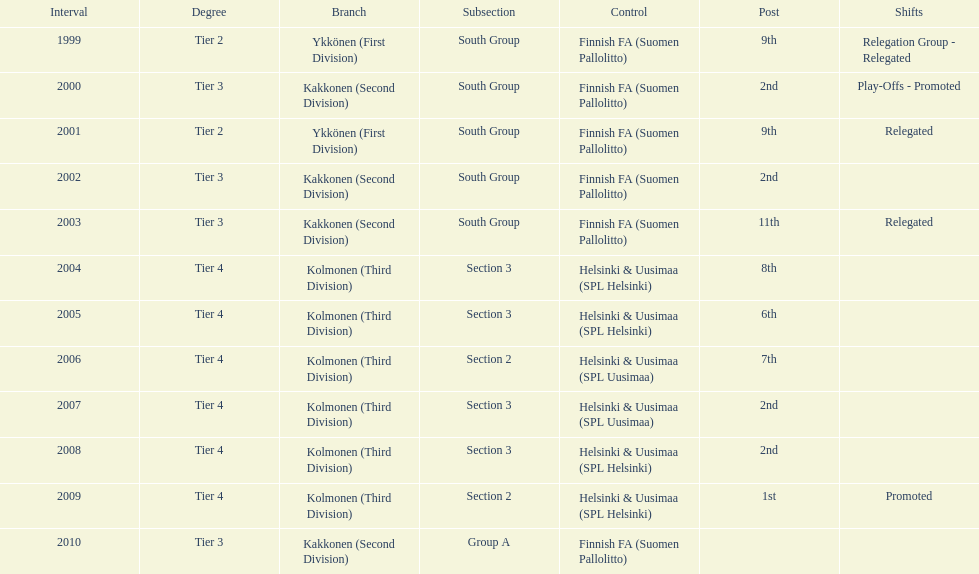How many times has this team been relegated? 3. 